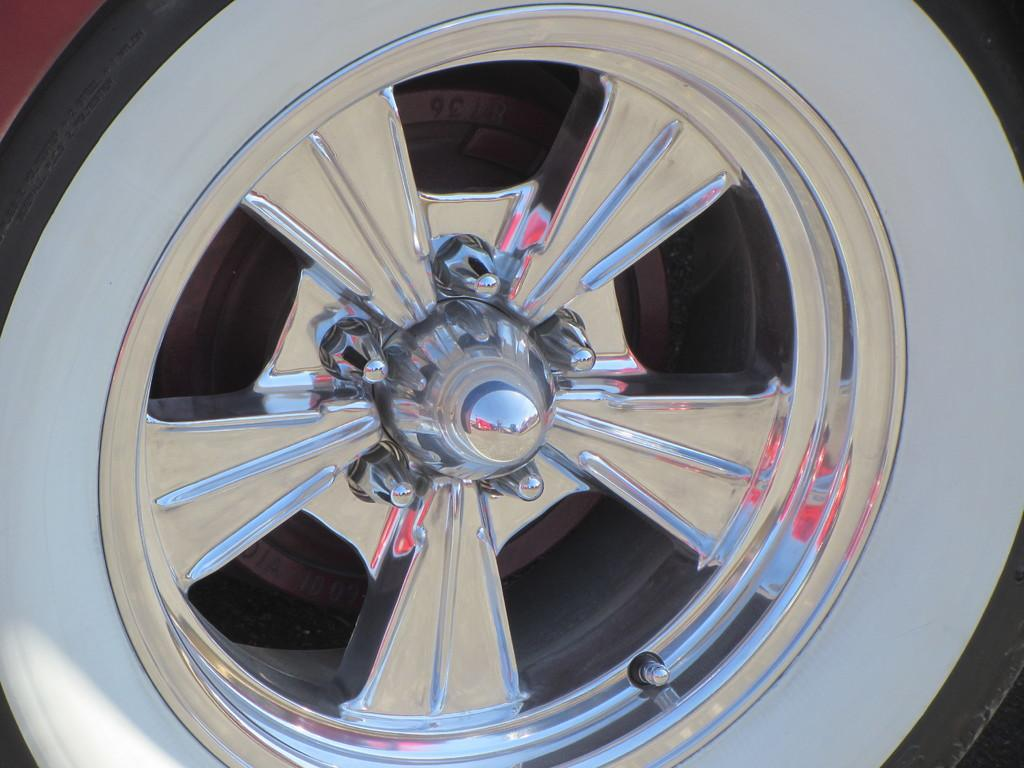What is the main subject of the image? The main subject of the image is a wheel of a car. What color is the orange in the image? There is no orange present in the image; it only features a wheel of a car. 